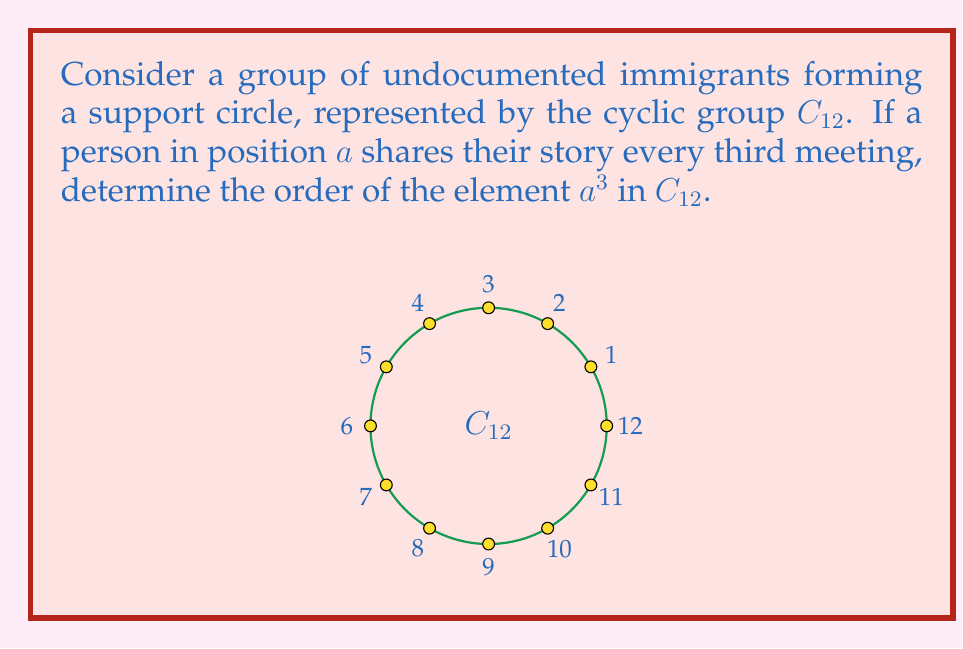Show me your answer to this math problem. To determine the order of $a^3$ in $C_{12}$, we follow these steps:

1) In $C_{12}$, the order of the group is 12.

2) The element $a$ generates the entire group, so $|a| = 12$.

3) We need to find the smallest positive integer $k$ such that $(a^3)^k = e$ (the identity element).

4) This is equivalent to finding the smallest $k$ where $3k \equiv 0 \pmod{12}$.

5) We can solve this by finding the least common multiple (LCM) of 3 and 12:
   $LCM(3,12) = \frac{3 \cdot 12}{GCD(3,12)} = \frac{36}{3} = 12$

6) Therefore, $k = 12/3 = 4$.

7) This means $(a^3)^4 = a^{12} = e$, and 4 is the smallest such positive integer.

Thus, the order of $a^3$ in $C_{12}$ is 4.
Answer: 4 